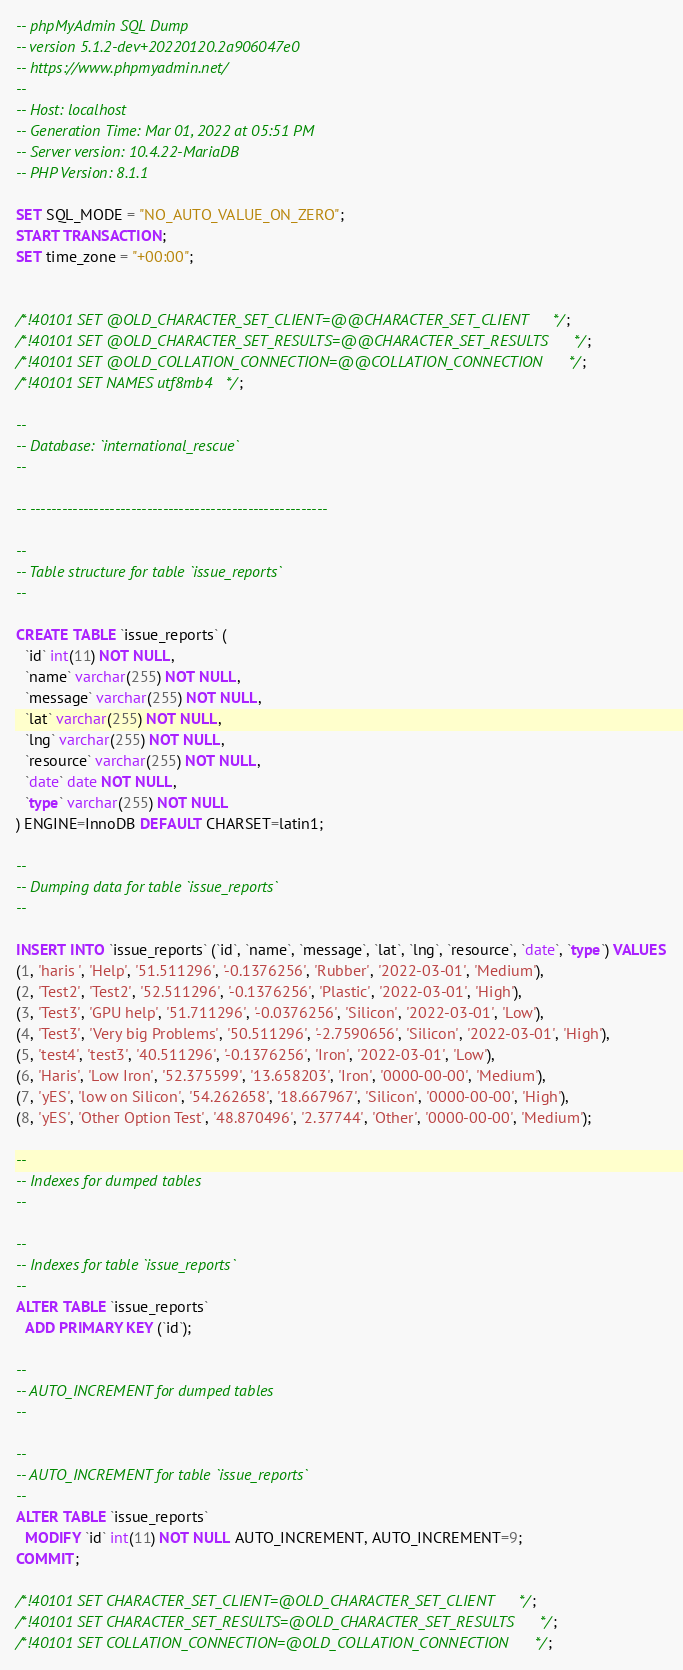Convert code to text. <code><loc_0><loc_0><loc_500><loc_500><_SQL_>-- phpMyAdmin SQL Dump
-- version 5.1.2-dev+20220120.2a906047e0
-- https://www.phpmyadmin.net/
--
-- Host: localhost
-- Generation Time: Mar 01, 2022 at 05:51 PM
-- Server version: 10.4.22-MariaDB
-- PHP Version: 8.1.1

SET SQL_MODE = "NO_AUTO_VALUE_ON_ZERO";
START TRANSACTION;
SET time_zone = "+00:00";


/*!40101 SET @OLD_CHARACTER_SET_CLIENT=@@CHARACTER_SET_CLIENT */;
/*!40101 SET @OLD_CHARACTER_SET_RESULTS=@@CHARACTER_SET_RESULTS */;
/*!40101 SET @OLD_COLLATION_CONNECTION=@@COLLATION_CONNECTION */;
/*!40101 SET NAMES utf8mb4 */;

--
-- Database: `international_rescue`
--

-- --------------------------------------------------------

--
-- Table structure for table `issue_reports`
--

CREATE TABLE `issue_reports` (
  `id` int(11) NOT NULL,
  `name` varchar(255) NOT NULL,
  `message` varchar(255) NOT NULL,
  `lat` varchar(255) NOT NULL,
  `lng` varchar(255) NOT NULL,
  `resource` varchar(255) NOT NULL,
  `date` date NOT NULL,
  `type` varchar(255) NOT NULL
) ENGINE=InnoDB DEFAULT CHARSET=latin1;

--
-- Dumping data for table `issue_reports`
--

INSERT INTO `issue_reports` (`id`, `name`, `message`, `lat`, `lng`, `resource`, `date`, `type`) VALUES
(1, 'haris ', 'Help', '51.511296', '-0.1376256', 'Rubber', '2022-03-01', 'Medium'),
(2, 'Test2', 'Test2', '52.511296', '-0.1376256', 'Plastic', '2022-03-01', 'High'),
(3, 'Test3', 'GPU help', '51.711296', '-0.0376256', 'Silicon', '2022-03-01', 'Low'),
(4, 'Test3', 'Very big Problems', '50.511296', '-2.7590656', 'Silicon', '2022-03-01', 'High'),
(5, 'test4', 'test3', '40.511296', '-0.1376256', 'Iron', '2022-03-01', 'Low'),
(6, 'Haris', 'Low Iron', '52.375599', '13.658203', 'Iron', '0000-00-00', 'Medium'),
(7, 'yES', 'low on Silicon', '54.262658', '18.667967', 'Silicon', '0000-00-00', 'High'),
(8, 'yES', 'Other Option Test', '48.870496', '2.37744', 'Other', '0000-00-00', 'Medium');

--
-- Indexes for dumped tables
--

--
-- Indexes for table `issue_reports`
--
ALTER TABLE `issue_reports`
  ADD PRIMARY KEY (`id`);

--
-- AUTO_INCREMENT for dumped tables
--

--
-- AUTO_INCREMENT for table `issue_reports`
--
ALTER TABLE `issue_reports`
  MODIFY `id` int(11) NOT NULL AUTO_INCREMENT, AUTO_INCREMENT=9;
COMMIT;

/*!40101 SET CHARACTER_SET_CLIENT=@OLD_CHARACTER_SET_CLIENT */;
/*!40101 SET CHARACTER_SET_RESULTS=@OLD_CHARACTER_SET_RESULTS */;
/*!40101 SET COLLATION_CONNECTION=@OLD_COLLATION_CONNECTION */;
</code> 